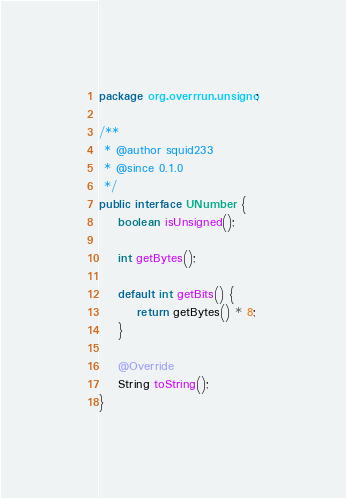<code> <loc_0><loc_0><loc_500><loc_500><_Java_>package org.overrrun.unsigno;

/**
 * @author squid233
 * @since 0.1.0
 */
public interface UNumber {
    boolean isUnsigned();

    int getBytes();

    default int getBits() {
        return getBytes() * 8;
    }

    @Override
    String toString();
}
</code> 